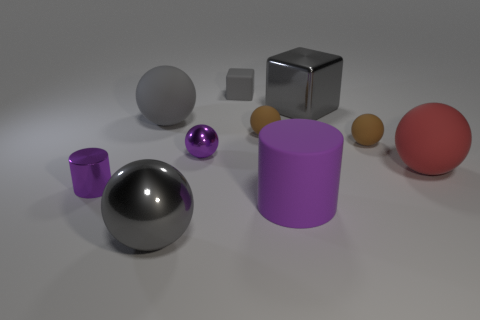How many objects are there and what are their colors? There are eight objects in this image. Starting from the left, there's a large purple cylinder, a large silver sphere, a small gray sphere, a medium gray cube, a small light-gray block, a small purple sphere, a small orange sphere, and a large red sphere. Each object brings its own hue to the scene, adding to the variety and visual interest. 